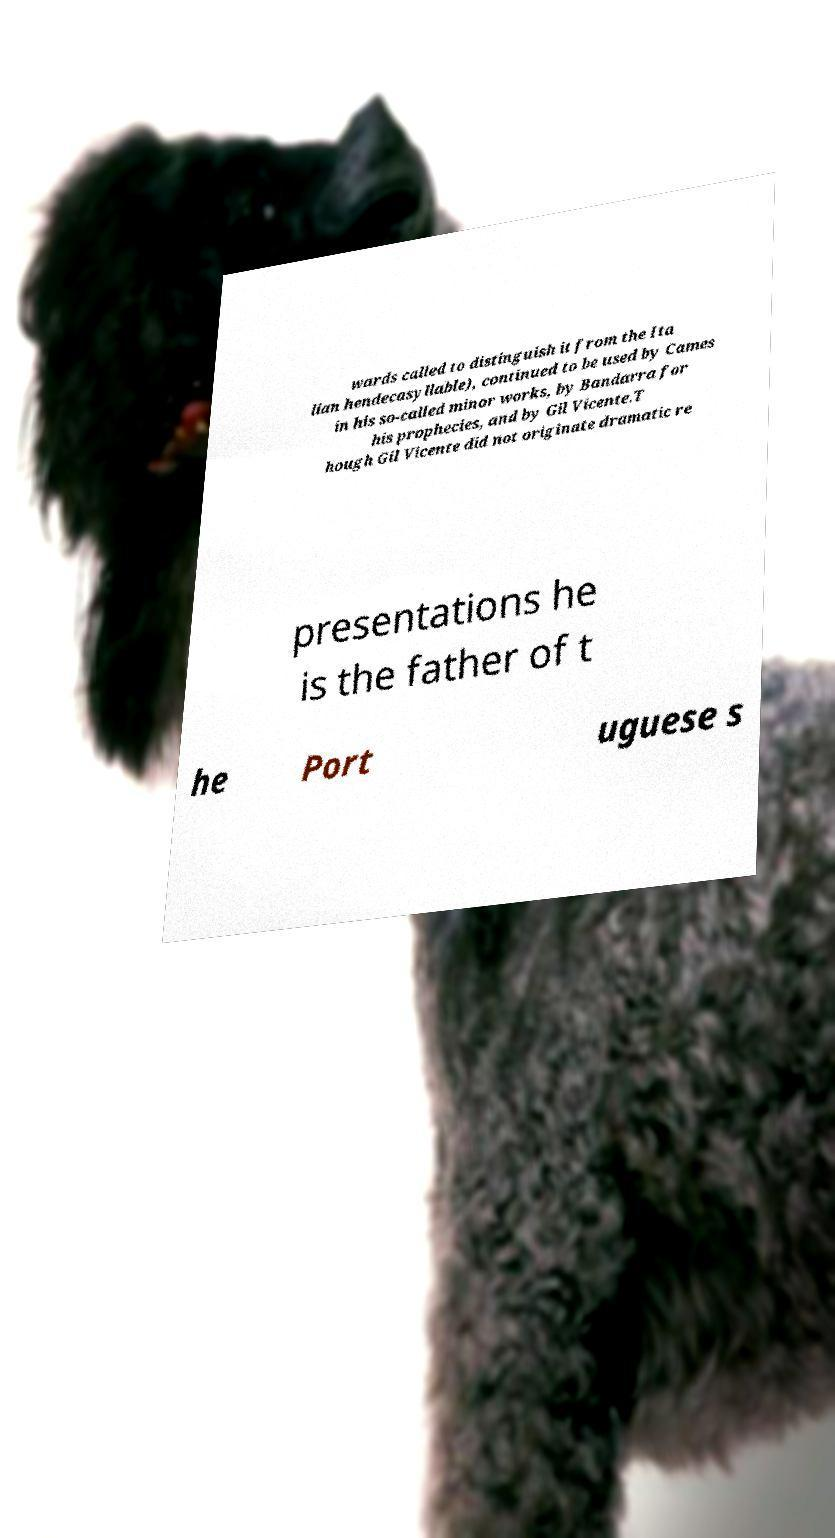Please read and relay the text visible in this image. What does it say? wards called to distinguish it from the Ita lian hendecasyllable), continued to be used by Cames in his so-called minor works, by Bandarra for his prophecies, and by Gil Vicente.T hough Gil Vicente did not originate dramatic re presentations he is the father of t he Port uguese s 